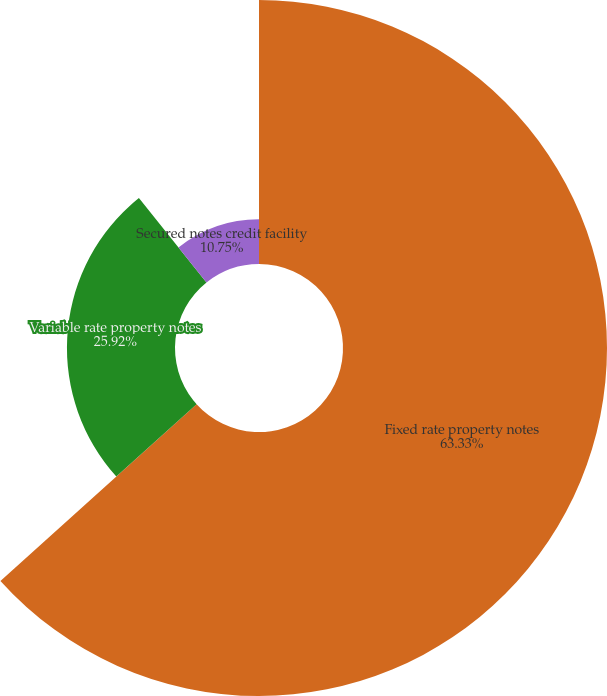Convert chart. <chart><loc_0><loc_0><loc_500><loc_500><pie_chart><fcel>Fixed rate property notes<fcel>Variable rate property notes<fcel>Secured notes credit facility<nl><fcel>63.33%<fcel>25.92%<fcel>10.75%<nl></chart> 